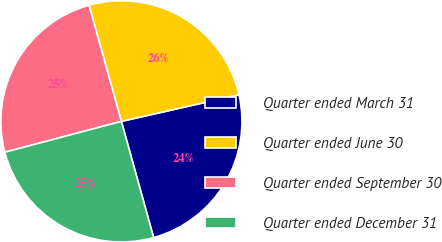<chart> <loc_0><loc_0><loc_500><loc_500><pie_chart><fcel>Quarter ended March 31<fcel>Quarter ended June 30<fcel>Quarter ended September 30<fcel>Quarter ended December 31<nl><fcel>24.24%<fcel>25.78%<fcel>24.79%<fcel>25.19%<nl></chart> 